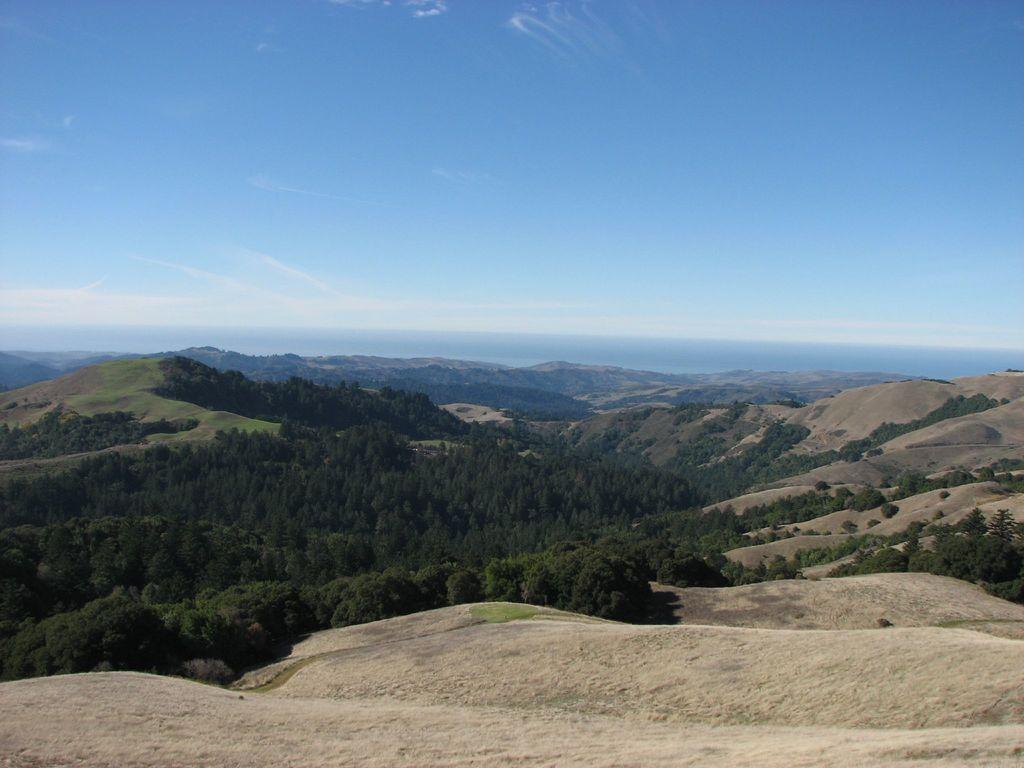Can you describe this image briefly? In this picture I can see trees, there are hills, and in the background there is the sky. 